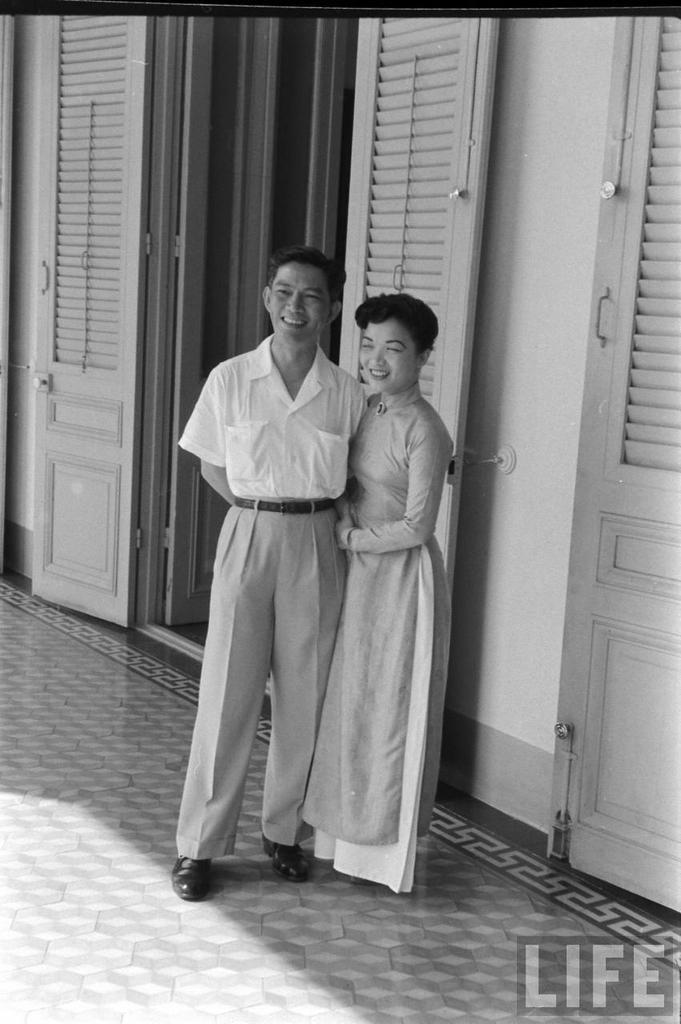Please provide a concise description of this image. In this image there is a floor. There are two people standing. There is a door behind the people. There is a wall. 